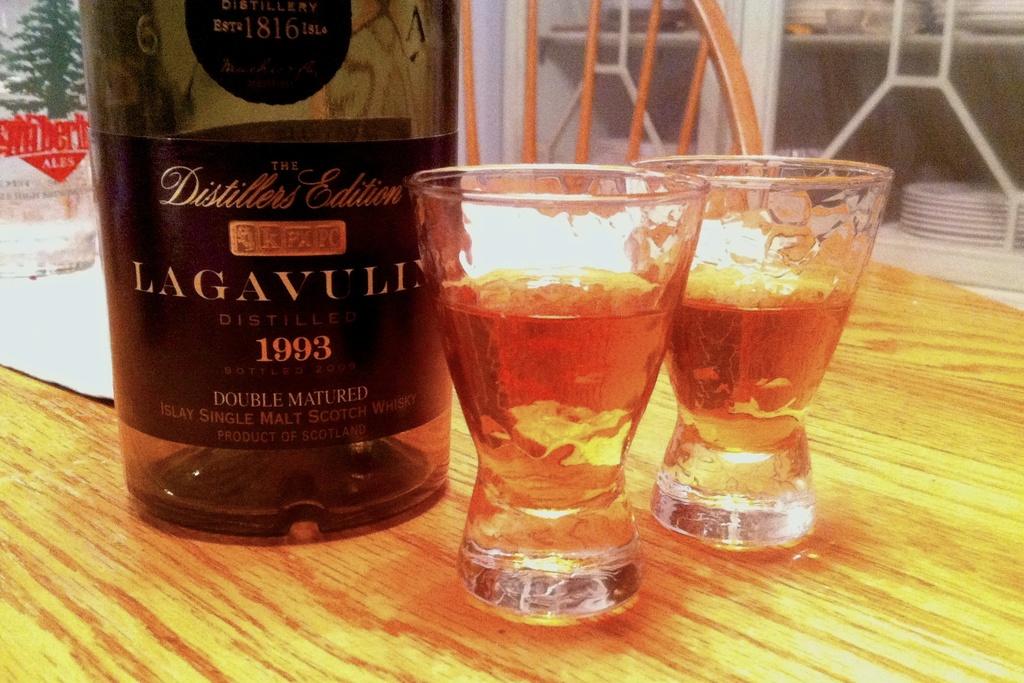What is the name of the wine?
Offer a very short reply. Lagavulin. 